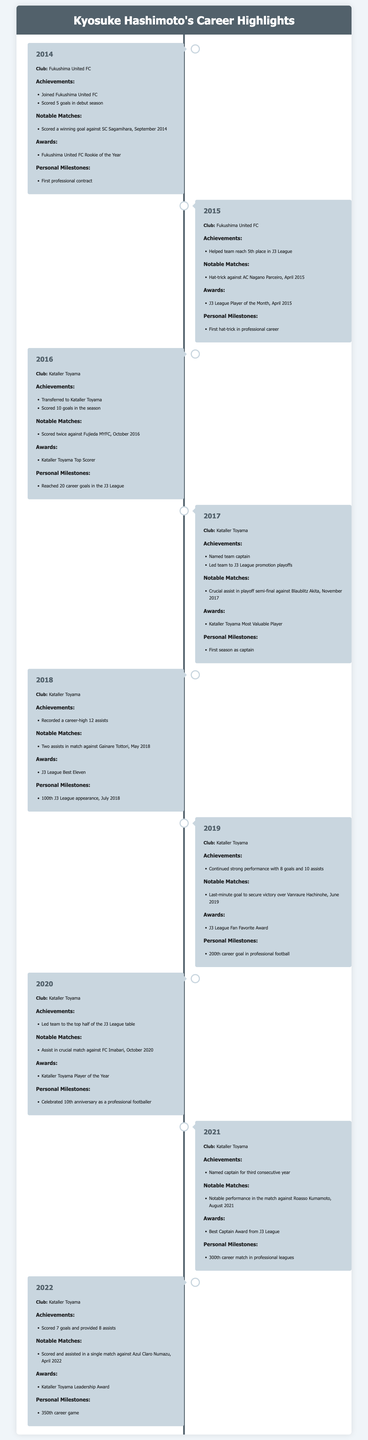what year did Kyosuke Hashimoto join Fukushima United FC? The document states that he joined Fukushima United FC in 2014.
Answer: 2014 how many goals did Kyosuke Hashimoto score in his debut season? The document mentions that he scored 5 goals in his debut season with Fukushima United FC.
Answer: 5 goals what award did Kyosuke Hashimoto receive in 2014? In 2014, he was awarded the Fukushima United FC Rookie of the Year.
Answer: Rookie of the Year which match featured a hat-trick scored by Kyosuke Hashimoto? The document indicates that he scored a hat-trick against AC Nagano Parceiro in April 2015.
Answer: AC Nagano Parceiro how many assists did Kyosuke Hashimoto record in 2018? The document states that he recorded a career-high 12 assists in 2018.
Answer: 12 assists what significant milestone did Kyosuke Hashimoto achieve in July 2018? He reached his 100th J3 League appearance in July 2018.
Answer: 100th J3 League appearance how many career goals did Kyosuke Hashimoto score by 2019? The document notes that he celebrated his 200th career goal in professional football in 2019.
Answer: 200th which award did he win as Kataller Toyama Player of the Year? The document specifies that he was named Kataller Toyama Player of the Year in 2020.
Answer: Player of the Year what position did Kyosuke Hashimoto take on the team in 2017? In 2017, he was named the team captain.
Answer: captain 